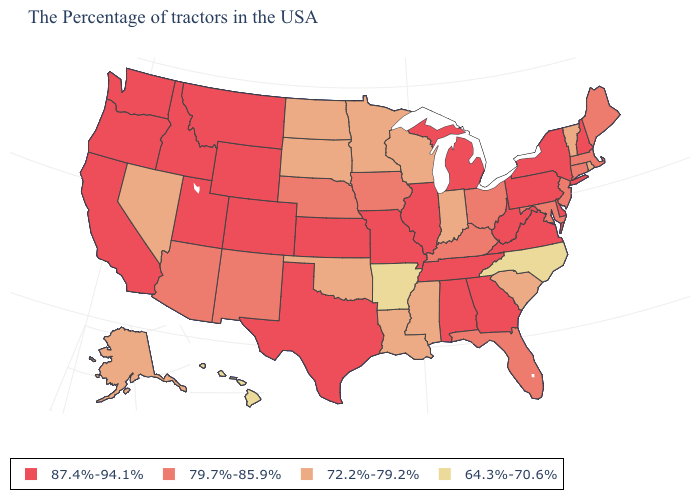Which states hav the highest value in the West?
Be succinct. Wyoming, Colorado, Utah, Montana, Idaho, California, Washington, Oregon. What is the value of Kansas?
Concise answer only. 87.4%-94.1%. What is the value of Ohio?
Quick response, please. 79.7%-85.9%. Does the map have missing data?
Give a very brief answer. No. What is the highest value in the MidWest ?
Quick response, please. 87.4%-94.1%. What is the value of Illinois?
Write a very short answer. 87.4%-94.1%. What is the value of Arkansas?
Answer briefly. 64.3%-70.6%. Name the states that have a value in the range 64.3%-70.6%?
Write a very short answer. North Carolina, Arkansas, Hawaii. Name the states that have a value in the range 72.2%-79.2%?
Quick response, please. Rhode Island, Vermont, South Carolina, Indiana, Wisconsin, Mississippi, Louisiana, Minnesota, Oklahoma, South Dakota, North Dakota, Nevada, Alaska. Does New Hampshire have a higher value than Delaware?
Write a very short answer. No. Among the states that border Massachusetts , which have the lowest value?
Short answer required. Rhode Island, Vermont. Name the states that have a value in the range 72.2%-79.2%?
Answer briefly. Rhode Island, Vermont, South Carolina, Indiana, Wisconsin, Mississippi, Louisiana, Minnesota, Oklahoma, South Dakota, North Dakota, Nevada, Alaska. Among the states that border North Carolina , which have the lowest value?
Give a very brief answer. South Carolina. Does Oregon have the same value as Minnesota?
Keep it brief. No. 